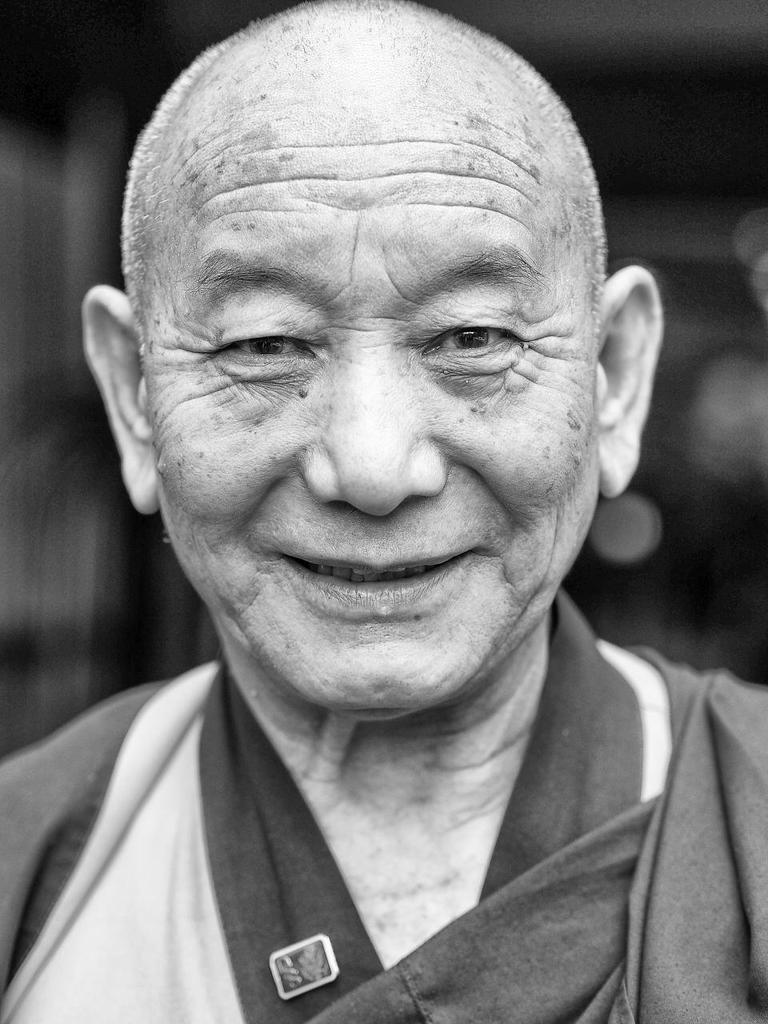Describe this image in one or two sentences. In this image in the foreground there is one man who is smiling, and the background is blurred. 